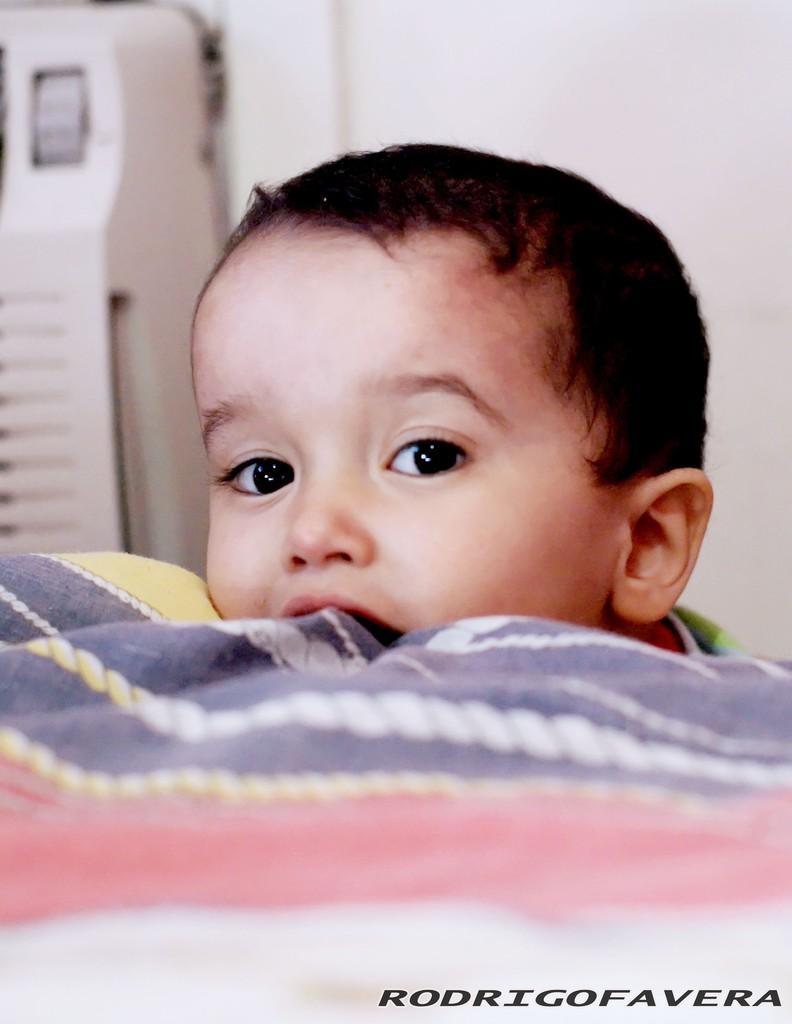Could you give a brief overview of what you see in this image? This is an edited picture. In this image there is a boy. In the foreground there is a cloth. At the back it looks like a cooler and there is a wall. At the bottom right there is text. 